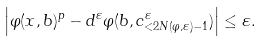<formula> <loc_0><loc_0><loc_500><loc_500>\left | \varphi ( x , b ) ^ { p } - d ^ { \varepsilon } \varphi ( b , c ^ { \varepsilon } _ { < 2 N ( \varphi , \varepsilon ) - 1 } ) \right | \leq \varepsilon .</formula> 